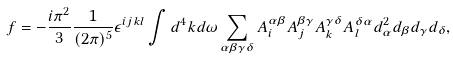Convert formula to latex. <formula><loc_0><loc_0><loc_500><loc_500>f = - \frac { i \pi ^ { 2 } } { 3 } \frac { 1 } { ( 2 \pi ) ^ { 5 } } \epsilon ^ { i j k l } \int d ^ { 4 } k d \omega \sum _ { \alpha \beta \gamma \delta } A ^ { \alpha \beta } _ { i } A _ { j } ^ { \beta \gamma } A _ { k } ^ { \gamma \delta } A _ { l } ^ { \delta \alpha } d _ { \alpha } ^ { 2 } d _ { \beta } d _ { \gamma } d _ { \delta } ,</formula> 